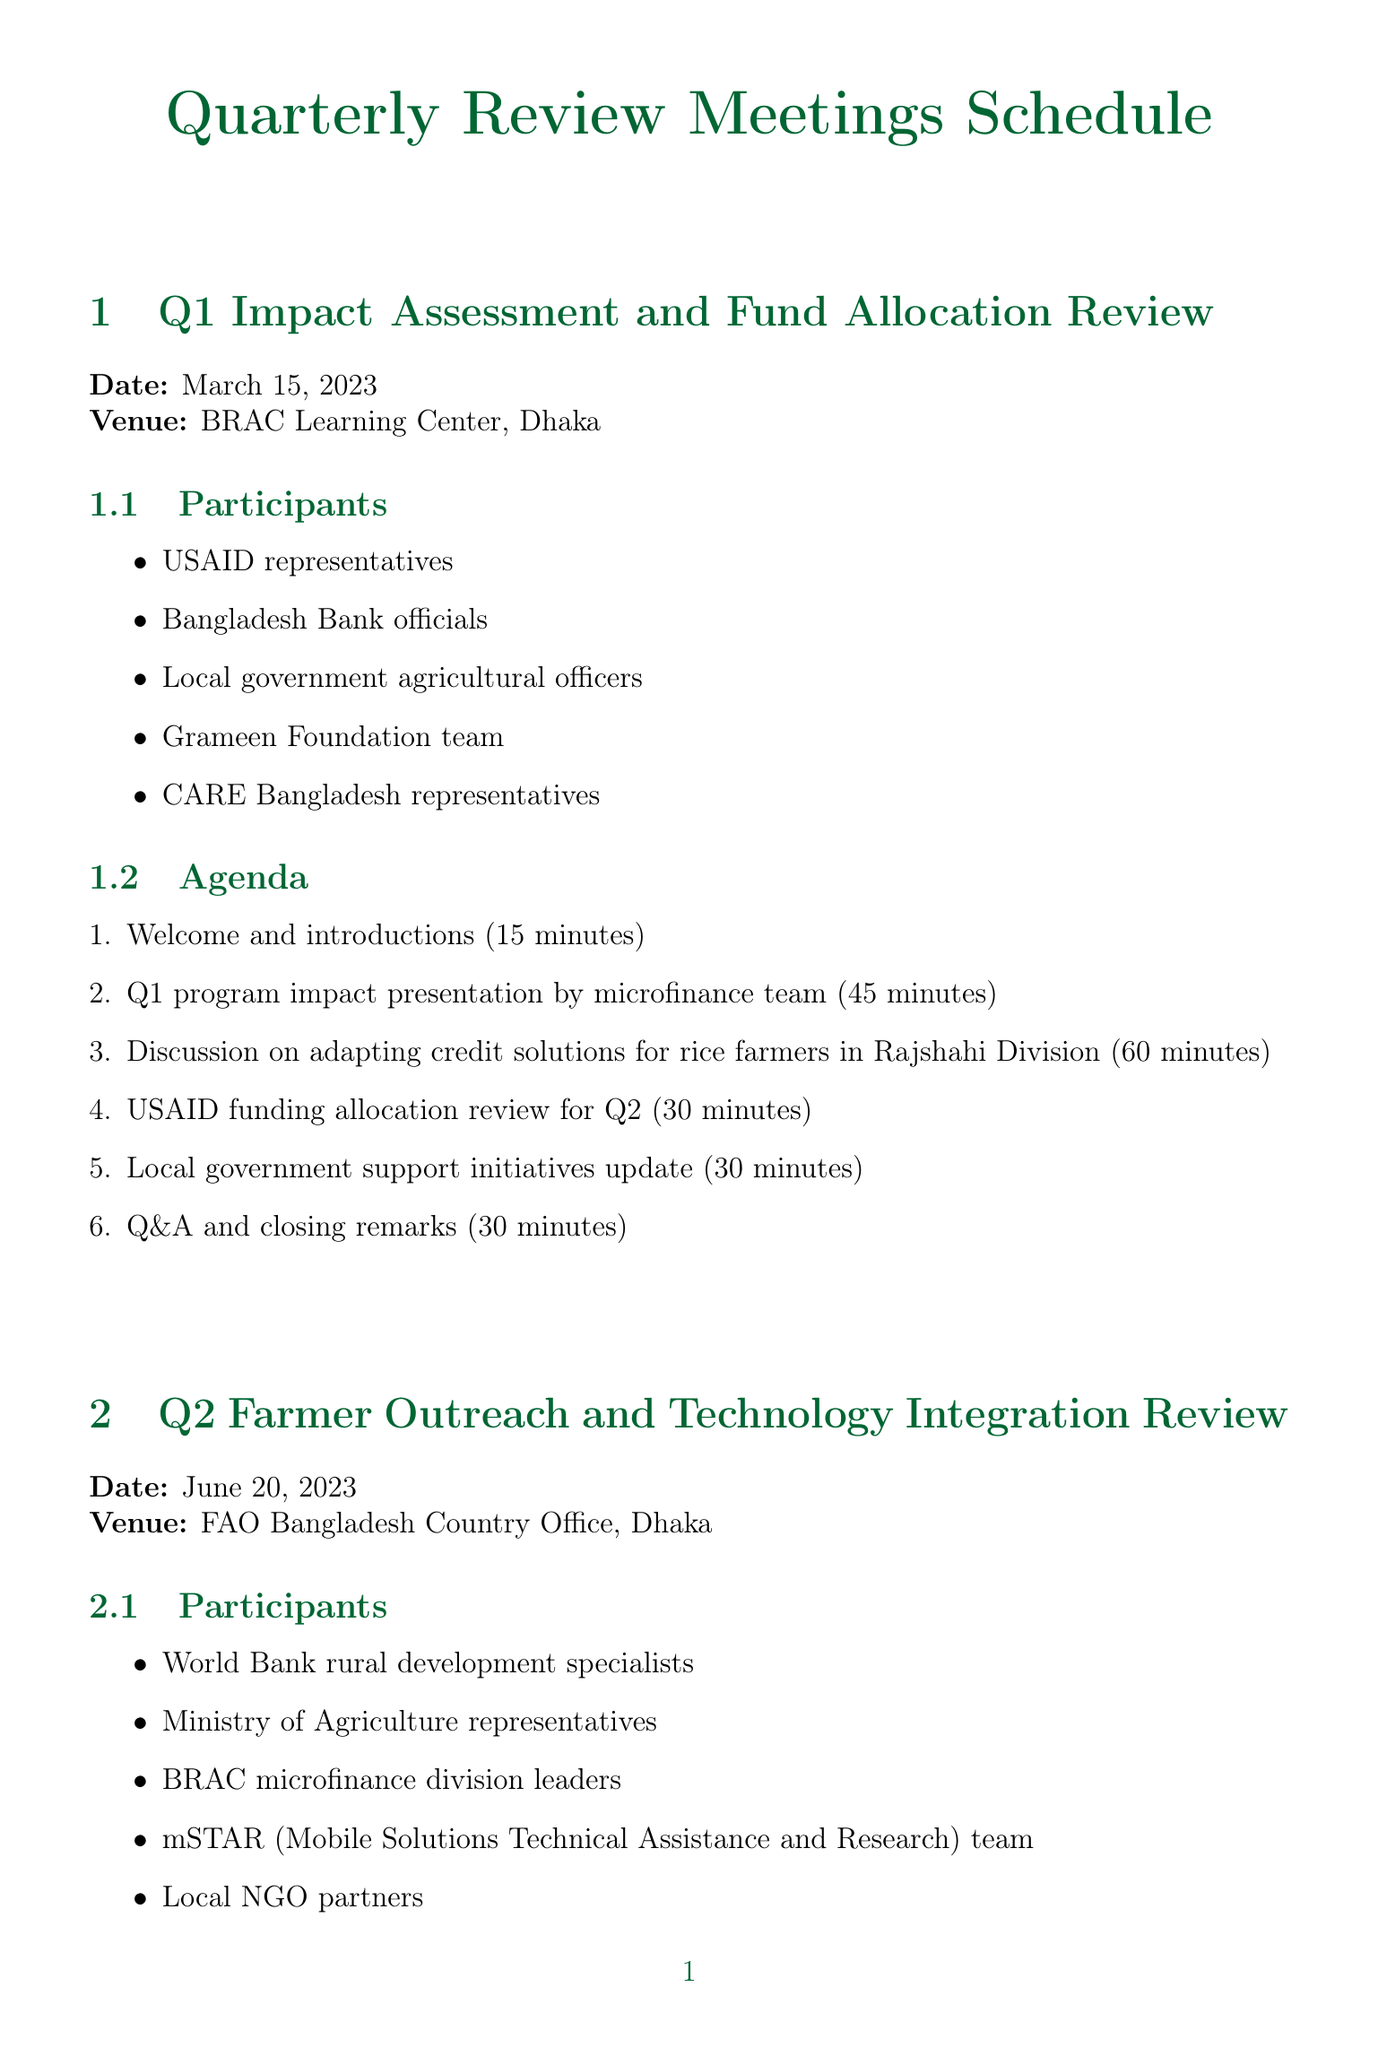what is the date of the Q1 meeting? The document states the date of the Q1 Impact Assessment and Fund Allocation Review meeting is March 15, 2023.
Answer: March 15, 2023 where is the Q2 meeting being held? The venue for the Q2 Farmer Outreach and Technology Integration Review is mentioned in the document as FAO Bangladesh Country Office, Dhaka.
Answer: FAO Bangladesh Country Office, Dhaka who are the participants in the Q3 meeting? The participants listed for the Q3 Climate Resilience and Sustainable Agriculture Finance Review meeting include GIZ representatives, Bangladesh Climate Change Trust officials, and others.
Answer: GIZ representatives, Bangladesh Climate Change Trust officials, Department of Agricultural Extension leaders, IFAD country team, Local microfinance institutions how long is the Q1 program impact presentation? The agenda for the Q1 meeting indicates that the program impact presentation by the microfinance team will take 45 minutes.
Answer: 45 minutes what topic is covered in the Q3 panel discussion? The document outlines that the panel discussion during the Q3 meeting will focus on integrating climate adaptation into microfinance products.
Answer: Integrating climate adaptation into microfinance products how many participants are listed for the Q4 meeting? The document specifies that there are five different participant groups listed for the Q4 Annual Review and Future Planning Session.
Answer: Five what is the main goal of the Q4 session? The agenda for the Q4 meeting states that one of the main goals is the 2024 program goals and strategy planning session.
Answer: 2024 program goals and strategy planning session who is providing technical support for agricultural value chain financing in Q4? The document indicates that FAO representatives are providing technical support for agricultural value chain financing during the Q4 meeting.
Answer: FAO representatives which organization is reviewing funding allocation for Q2 during the Q1 meeting? USAID is mentioned in the document as the organization reviewing funding allocation for Q2 at the Q1 meeting.
Answer: USAID 